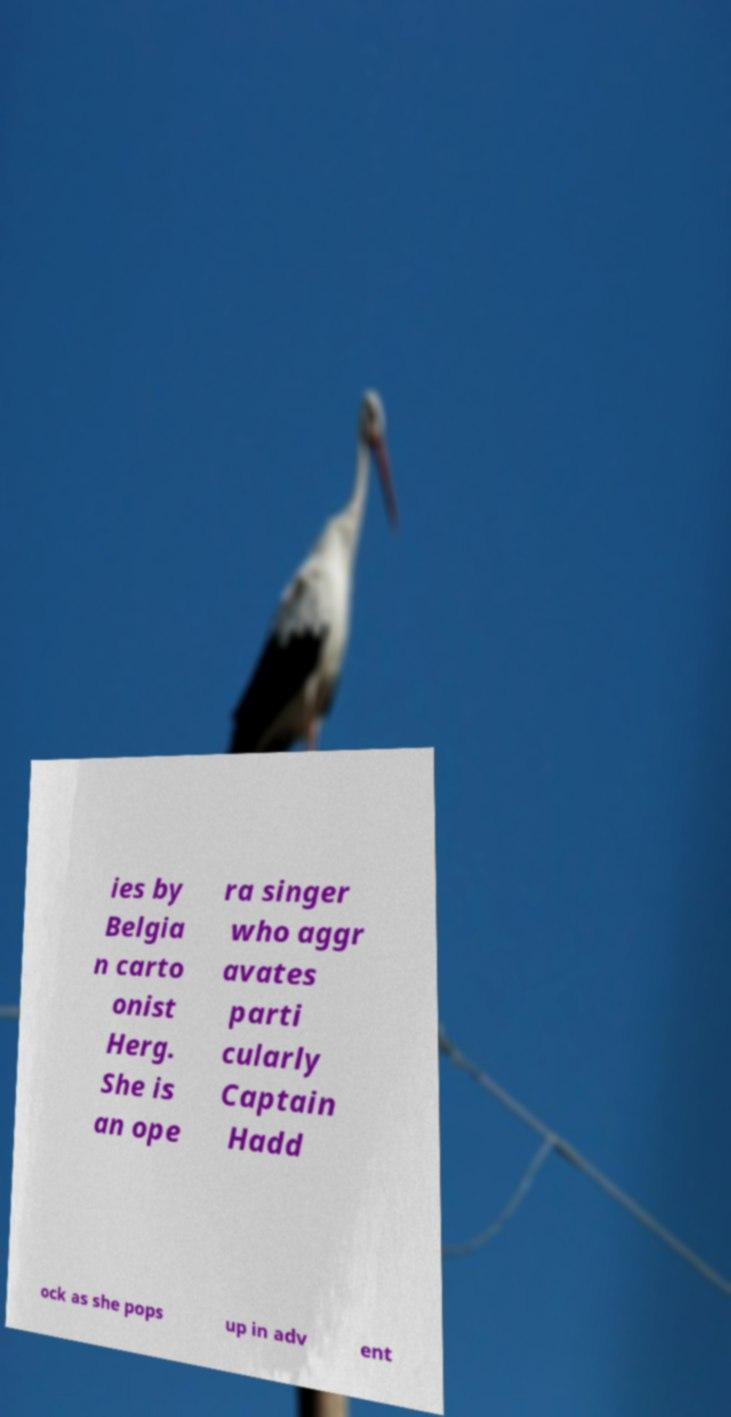Could you extract and type out the text from this image? ies by Belgia n carto onist Herg. She is an ope ra singer who aggr avates parti cularly Captain Hadd ock as she pops up in adv ent 